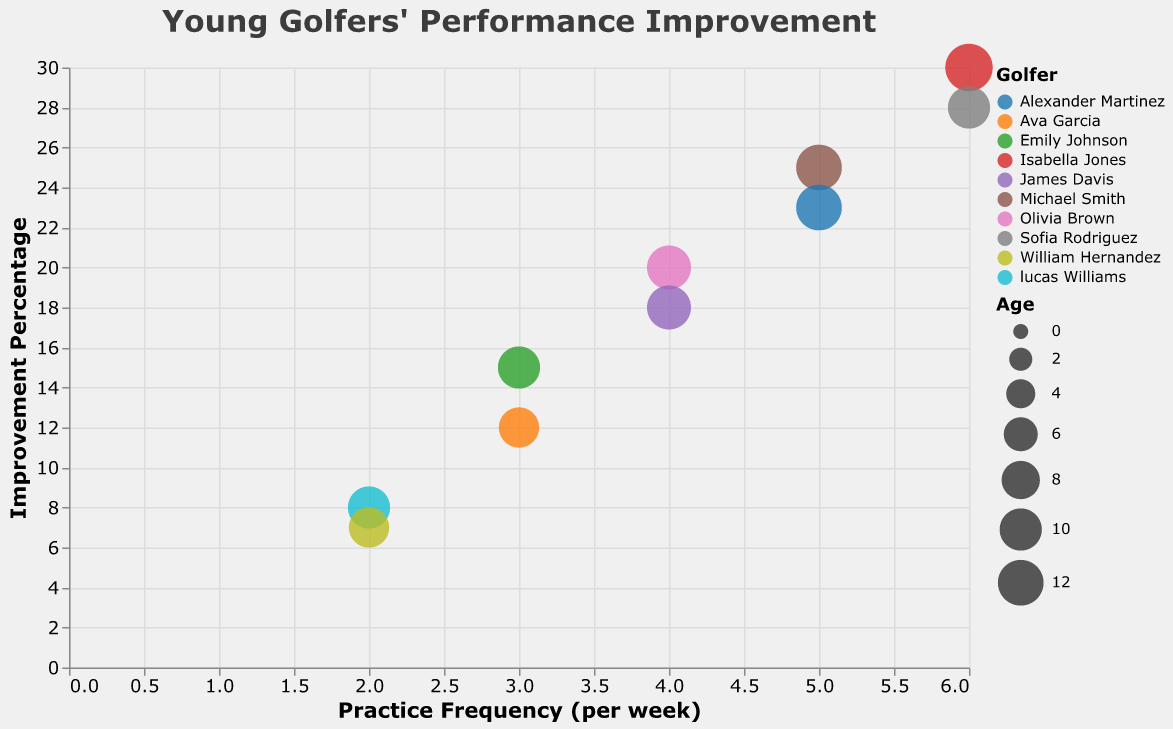Which golfer has the highest improvement percentage? Look at the vertical axis which shows the Improvement Percentage. Identify the bubble that is at the highest position on this axis.
Answer: Isabella Jones What is the practice frequency per week for Alexander Martinez? Find the bubble corresponding to Alexander Martinez and refer to its position on the horizontal axis which represents Practice Frequency (per week).
Answer: 5 times per week Which golfer is the youngest? Refer to the size of the bubbles which represent the Age. The smallest bubble indicates the youngest golfer.
Answer: Ava Garcia What is the range of improvement percentages among all golfers? Identify the highest and lowest bubbles along the vertical axis (Improvement Percentage). The highest is 30% (Isabella Jones), and the lowest is 7% (William Hernandez). Subtract the lowest from the highest to get the range.
Answer: 23% Who has a higher improvement percentage, Emily Johnson or Lucas Williams? Locate the bubbles for Emily Johnson and Lucas Williams and compare their positions on the vertical axis. Emily Johnson's bubble is higher than Lucas Williams'.
Answer: Emily Johnson How does the practice frequency (per week) of Sofia Rodriguez compare to James Davis? Compare the positions of Sofia Rodriguez's and James Davis' bubbles on the horizontal axis. Sofia Rodriguez's bubble is further to the right.
Answer: Sofia Rodriguez practices more frequently What is the average improvement percentage of the golfers practicing 4 times per week? Identify the bubbles for the golfers practicing 4 times per week (Olivia Brown and James Davis), sum their improvement percentages (20 + 18 = 38), and divide by the number of golfers (2) to get the average.
Answer: 19% Which golfer, among those aged 12, has the highest improvement percentage? Identify the bubbles for golfers aged 12 (Michael Smith and Alexander Martinez) by looking at the tooltip or bubble size. Compare their positions on the vertical axis. Michael Smith's bubble is higher.
Answer: Michael Smith Which age group has the largest bubble? Examine the legend indicating the size of the bubbles which represent Age. The largest bubbles correspond to the highest age group (13 years old).
Answer: 13 years old Is there a correlation between practice frequency and improvement percentage? Observe if there's a trend or pattern where bubbles with higher practice frequency (right side of the horizontal axis) also tend to have a higher improvement percentage (top side of the vertical axis).
Answer: Yes 